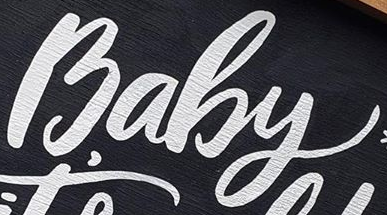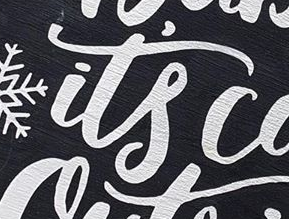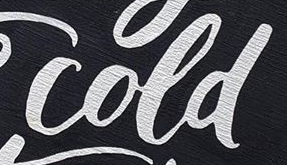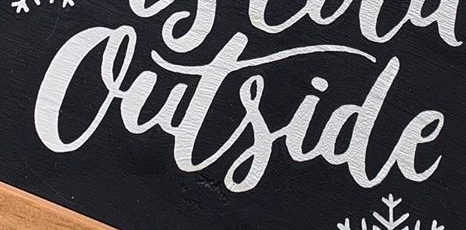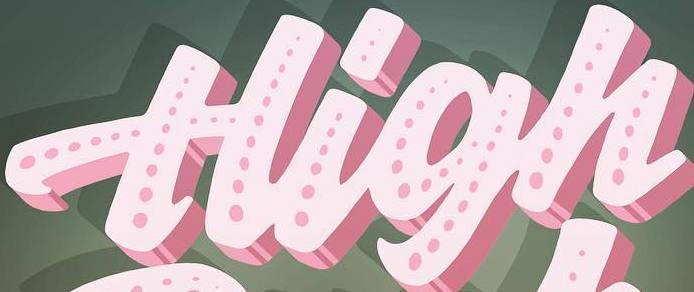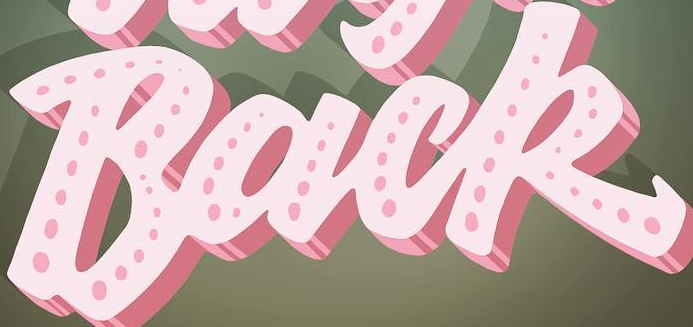Read the text from these images in sequence, separated by a semicolon. Baby; it's; cold; Outside; High; Back 